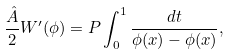Convert formula to latex. <formula><loc_0><loc_0><loc_500><loc_500>\frac { \hat { A } } { 2 } W ^ { \prime } ( \phi ) = P \int _ { 0 } ^ { 1 } \frac { d t } { \phi ( x ) - \phi ( x ) } ,</formula> 